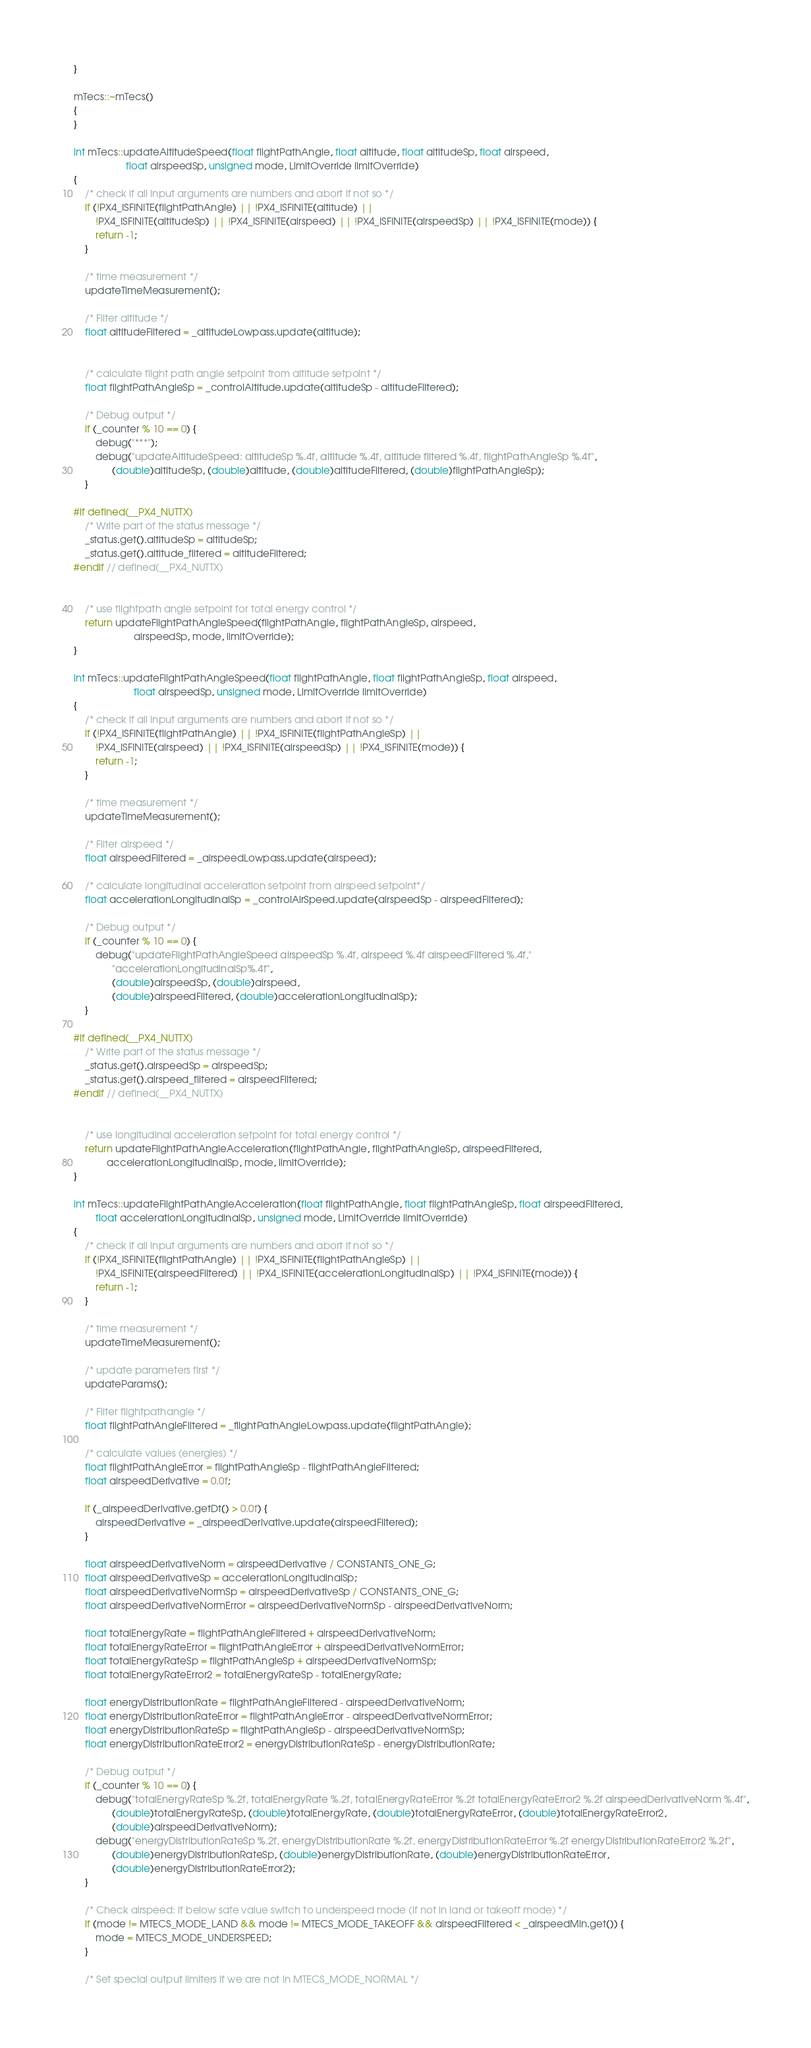Convert code to text. <code><loc_0><loc_0><loc_500><loc_500><_C++_>}

mTecs::~mTecs()
{
}

int mTecs::updateAltitudeSpeed(float flightPathAngle, float altitude, float altitudeSp, float airspeed,
			       float airspeedSp, unsigned mode, LimitOverride limitOverride)
{
	/* check if all input arguments are numbers and abort if not so */
	if (!PX4_ISFINITE(flightPathAngle) || !PX4_ISFINITE(altitude) ||
	    !PX4_ISFINITE(altitudeSp) || !PX4_ISFINITE(airspeed) || !PX4_ISFINITE(airspeedSp) || !PX4_ISFINITE(mode)) {
		return -1;
	}

	/* time measurement */
	updateTimeMeasurement();

	/* Filter altitude */
	float altitudeFiltered = _altitudeLowpass.update(altitude);


	/* calculate flight path angle setpoint from altitude setpoint */
	float flightPathAngleSp = _controlAltitude.update(altitudeSp - altitudeFiltered);

	/* Debug output */
	if (_counter % 10 == 0) {
		debug("***");
		debug("updateAltitudeSpeed: altitudeSp %.4f, altitude %.4f, altitude filtered %.4f, flightPathAngleSp %.4f",
		      (double)altitudeSp, (double)altitude, (double)altitudeFiltered, (double)flightPathAngleSp);
	}

#if defined(__PX4_NUTTX)
	/* Write part of the status message */
	_status.get().altitudeSp = altitudeSp;
	_status.get().altitude_filtered = altitudeFiltered;
#endif // defined(__PX4_NUTTX)


	/* use flightpath angle setpoint for total energy control */
	return updateFlightPathAngleSpeed(flightPathAngle, flightPathAngleSp, airspeed,
					  airspeedSp, mode, limitOverride);
}

int mTecs::updateFlightPathAngleSpeed(float flightPathAngle, float flightPathAngleSp, float airspeed,
				      float airspeedSp, unsigned mode, LimitOverride limitOverride)
{
	/* check if all input arguments are numbers and abort if not so */
	if (!PX4_ISFINITE(flightPathAngle) || !PX4_ISFINITE(flightPathAngleSp) ||
	    !PX4_ISFINITE(airspeed) || !PX4_ISFINITE(airspeedSp) || !PX4_ISFINITE(mode)) {
		return -1;
	}

	/* time measurement */
	updateTimeMeasurement();

	/* Filter airspeed */
	float airspeedFiltered = _airspeedLowpass.update(airspeed);

	/* calculate longitudinal acceleration setpoint from airspeed setpoint*/
	float accelerationLongitudinalSp = _controlAirSpeed.update(airspeedSp - airspeedFiltered);

	/* Debug output */
	if (_counter % 10 == 0) {
		debug("updateFlightPathAngleSpeed airspeedSp %.4f, airspeed %.4f airspeedFiltered %.4f,"
		      "accelerationLongitudinalSp%.4f",
		      (double)airspeedSp, (double)airspeed,
		      (double)airspeedFiltered, (double)accelerationLongitudinalSp);
	}

#if defined(__PX4_NUTTX)
	/* Write part of the status message */
	_status.get().airspeedSp = airspeedSp;
	_status.get().airspeed_filtered = airspeedFiltered;
#endif // defined(__PX4_NUTTX)


	/* use longitudinal acceleration setpoint for total energy control */
	return updateFlightPathAngleAcceleration(flightPathAngle, flightPathAngleSp, airspeedFiltered,
			accelerationLongitudinalSp, mode, limitOverride);
}

int mTecs::updateFlightPathAngleAcceleration(float flightPathAngle, float flightPathAngleSp, float airspeedFiltered,
		float accelerationLongitudinalSp, unsigned mode, LimitOverride limitOverride)
{
	/* check if all input arguments are numbers and abort if not so */
	if (!PX4_ISFINITE(flightPathAngle) || !PX4_ISFINITE(flightPathAngleSp) ||
	    !PX4_ISFINITE(airspeedFiltered) || !PX4_ISFINITE(accelerationLongitudinalSp) || !PX4_ISFINITE(mode)) {
		return -1;
	}

	/* time measurement */
	updateTimeMeasurement();

	/* update parameters first */
	updateParams();

	/* Filter flightpathangle */
	float flightPathAngleFiltered = _flightPathAngleLowpass.update(flightPathAngle);

	/* calculate values (energies) */
	float flightPathAngleError = flightPathAngleSp - flightPathAngleFiltered;
	float airspeedDerivative = 0.0f;

	if (_airspeedDerivative.getDt() > 0.0f) {
		airspeedDerivative = _airspeedDerivative.update(airspeedFiltered);
	}

	float airspeedDerivativeNorm = airspeedDerivative / CONSTANTS_ONE_G;
	float airspeedDerivativeSp = accelerationLongitudinalSp;
	float airspeedDerivativeNormSp = airspeedDerivativeSp / CONSTANTS_ONE_G;
	float airspeedDerivativeNormError = airspeedDerivativeNormSp - airspeedDerivativeNorm;

	float totalEnergyRate = flightPathAngleFiltered + airspeedDerivativeNorm;
	float totalEnergyRateError = flightPathAngleError + airspeedDerivativeNormError;
	float totalEnergyRateSp = flightPathAngleSp + airspeedDerivativeNormSp;
	float totalEnergyRateError2 = totalEnergyRateSp - totalEnergyRate;

	float energyDistributionRate = flightPathAngleFiltered - airspeedDerivativeNorm;
	float energyDistributionRateError = flightPathAngleError - airspeedDerivativeNormError;
	float energyDistributionRateSp = flightPathAngleSp - airspeedDerivativeNormSp;
	float energyDistributionRateError2 = energyDistributionRateSp - energyDistributionRate;

	/* Debug output */
	if (_counter % 10 == 0) {
		debug("totalEnergyRateSp %.2f, totalEnergyRate %.2f, totalEnergyRateError %.2f totalEnergyRateError2 %.2f airspeedDerivativeNorm %.4f",
		      (double)totalEnergyRateSp, (double)totalEnergyRate, (double)totalEnergyRateError, (double)totalEnergyRateError2,
		      (double)airspeedDerivativeNorm);
		debug("energyDistributionRateSp %.2f, energyDistributionRate %.2f, energyDistributionRateError %.2f energyDistributionRateError2 %.2f",
		      (double)energyDistributionRateSp, (double)energyDistributionRate, (double)energyDistributionRateError,
		      (double)energyDistributionRateError2);
	}

	/* Check airspeed: if below safe value switch to underspeed mode (if not in land or takeoff mode) */
	if (mode != MTECS_MODE_LAND && mode != MTECS_MODE_TAKEOFF && airspeedFiltered < _airspeedMin.get()) {
		mode = MTECS_MODE_UNDERSPEED;
	}

	/* Set special output limiters if we are not in MTECS_MODE_NORMAL */</code> 